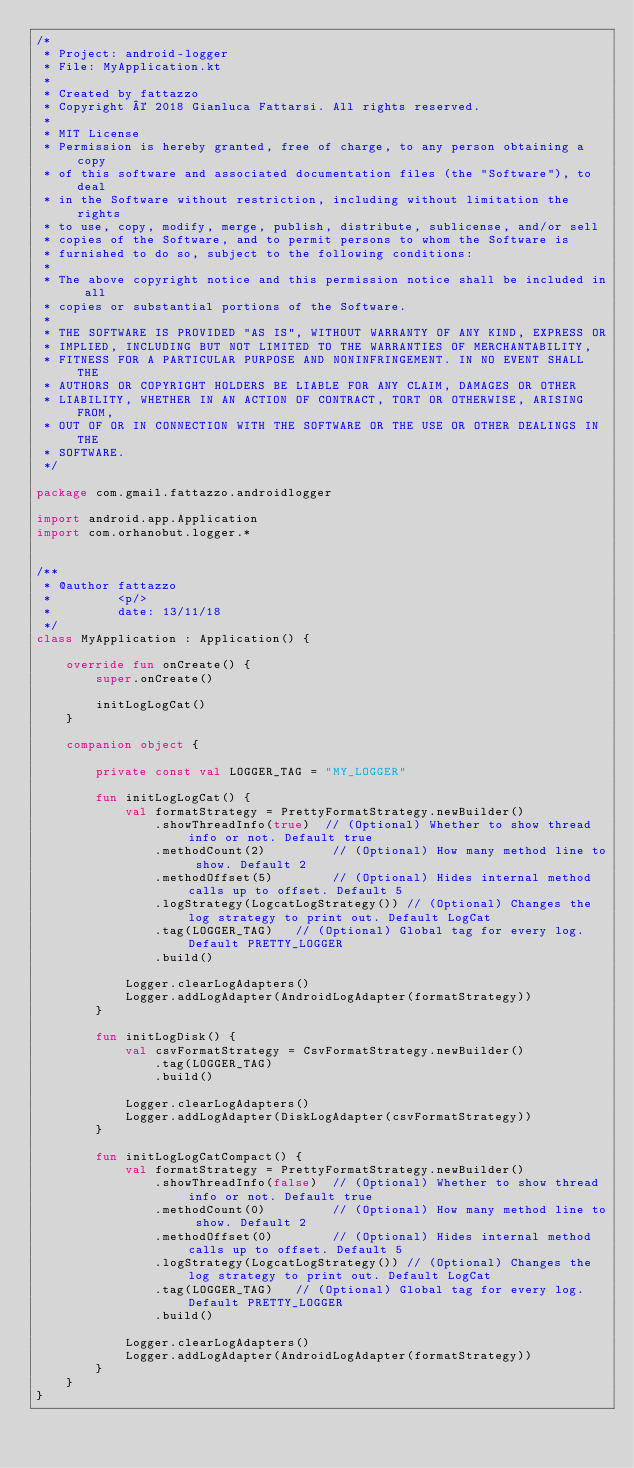Convert code to text. <code><loc_0><loc_0><loc_500><loc_500><_Kotlin_>/*
 * Project: android-logger
 * File: MyApplication.kt
 *
 * Created by fattazzo
 * Copyright © 2018 Gianluca Fattarsi. All rights reserved.
 *
 * MIT License
 * Permission is hereby granted, free of charge, to any person obtaining a copy
 * of this software and associated documentation files (the "Software"), to deal
 * in the Software without restriction, including without limitation the rights
 * to use, copy, modify, merge, publish, distribute, sublicense, and/or sell
 * copies of the Software, and to permit persons to whom the Software is
 * furnished to do so, subject to the following conditions:
 *
 * The above copyright notice and this permission notice shall be included in all
 * copies or substantial portions of the Software.
 *
 * THE SOFTWARE IS PROVIDED "AS IS", WITHOUT WARRANTY OF ANY KIND, EXPRESS OR
 * IMPLIED, INCLUDING BUT NOT LIMITED TO THE WARRANTIES OF MERCHANTABILITY,
 * FITNESS FOR A PARTICULAR PURPOSE AND NONINFRINGEMENT. IN NO EVENT SHALL THE
 * AUTHORS OR COPYRIGHT HOLDERS BE LIABLE FOR ANY CLAIM, DAMAGES OR OTHER
 * LIABILITY, WHETHER IN AN ACTION OF CONTRACT, TORT OR OTHERWISE, ARISING FROM,
 * OUT OF OR IN CONNECTION WITH THE SOFTWARE OR THE USE OR OTHER DEALINGS IN THE
 * SOFTWARE.
 */

package com.gmail.fattazzo.androidlogger

import android.app.Application
import com.orhanobut.logger.*


/**
 * @author fattazzo
 *         <p/>
 *         date: 13/11/18
 */
class MyApplication : Application() {

    override fun onCreate() {
        super.onCreate()

        initLogLogCat()
    }

    companion object {

        private const val LOGGER_TAG = "MY_LOGGER"

        fun initLogLogCat() {
            val formatStrategy = PrettyFormatStrategy.newBuilder()
                .showThreadInfo(true)  // (Optional) Whether to show thread info or not. Default true
                .methodCount(2)         // (Optional) How many method line to show. Default 2
                .methodOffset(5)        // (Optional) Hides internal method calls up to offset. Default 5
                .logStrategy(LogcatLogStrategy()) // (Optional) Changes the log strategy to print out. Default LogCat
                .tag(LOGGER_TAG)   // (Optional) Global tag for every log. Default PRETTY_LOGGER
                .build()

            Logger.clearLogAdapters()
            Logger.addLogAdapter(AndroidLogAdapter(formatStrategy))
        }

        fun initLogDisk() {
            val csvFormatStrategy = CsvFormatStrategy.newBuilder()
                .tag(LOGGER_TAG)
                .build()

            Logger.clearLogAdapters()
            Logger.addLogAdapter(DiskLogAdapter(csvFormatStrategy))
        }

        fun initLogLogCatCompact() {
            val formatStrategy = PrettyFormatStrategy.newBuilder()
                .showThreadInfo(false)  // (Optional) Whether to show thread info or not. Default true
                .methodCount(0)         // (Optional) How many method line to show. Default 2
                .methodOffset(0)        // (Optional) Hides internal method calls up to offset. Default 5
                .logStrategy(LogcatLogStrategy()) // (Optional) Changes the log strategy to print out. Default LogCat
                .tag(LOGGER_TAG)   // (Optional) Global tag for every log. Default PRETTY_LOGGER
                .build()

            Logger.clearLogAdapters()
            Logger.addLogAdapter(AndroidLogAdapter(formatStrategy))
        }
    }
}</code> 